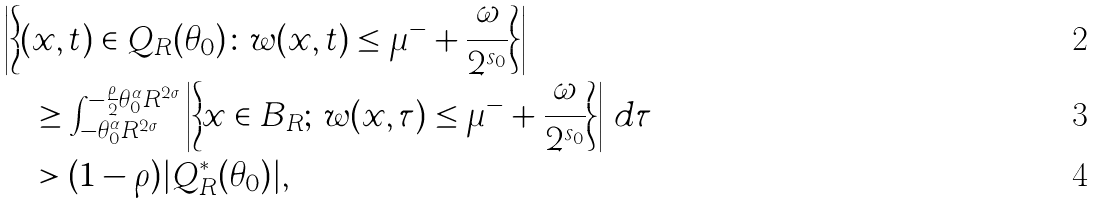Convert formula to latex. <formula><loc_0><loc_0><loc_500><loc_500>& \left | \left \{ ( x , t ) \in Q _ { R } ( \theta _ { 0 } ) \colon w ( x , t ) \leq \mu ^ { - } + \frac { \omega } { 2 ^ { s _ { 0 } } } \right \} \right | \\ & \quad \geq \int _ { - \theta _ { 0 } ^ { \alpha } R ^ { 2 \sigma } } ^ { - \frac { \rho } { 2 } \theta _ { 0 } ^ { \alpha } R ^ { 2 \sigma } } \left | \left \{ x \in B _ { R } ; \, w ( x , \tau ) \leq \mu ^ { - } + \frac { \omega } { 2 ^ { s _ { 0 } } } \right \} \right | \, d \tau \\ & \quad > ( 1 - \rho ) | Q ^ { \ast } _ { R } ( \theta _ { 0 } ) | ,</formula> 